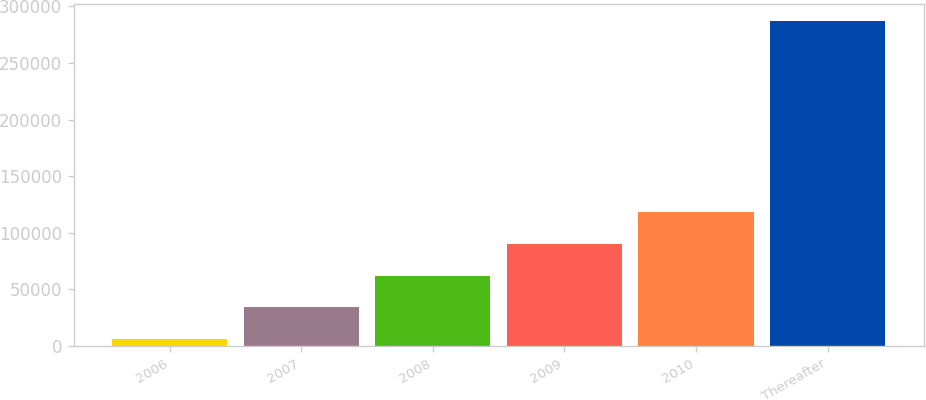<chart> <loc_0><loc_0><loc_500><loc_500><bar_chart><fcel>2006<fcel>2007<fcel>2008<fcel>2009<fcel>2010<fcel>Thereafter<nl><fcel>5694<fcel>33880.8<fcel>62067.6<fcel>90254.4<fcel>118441<fcel>287562<nl></chart> 